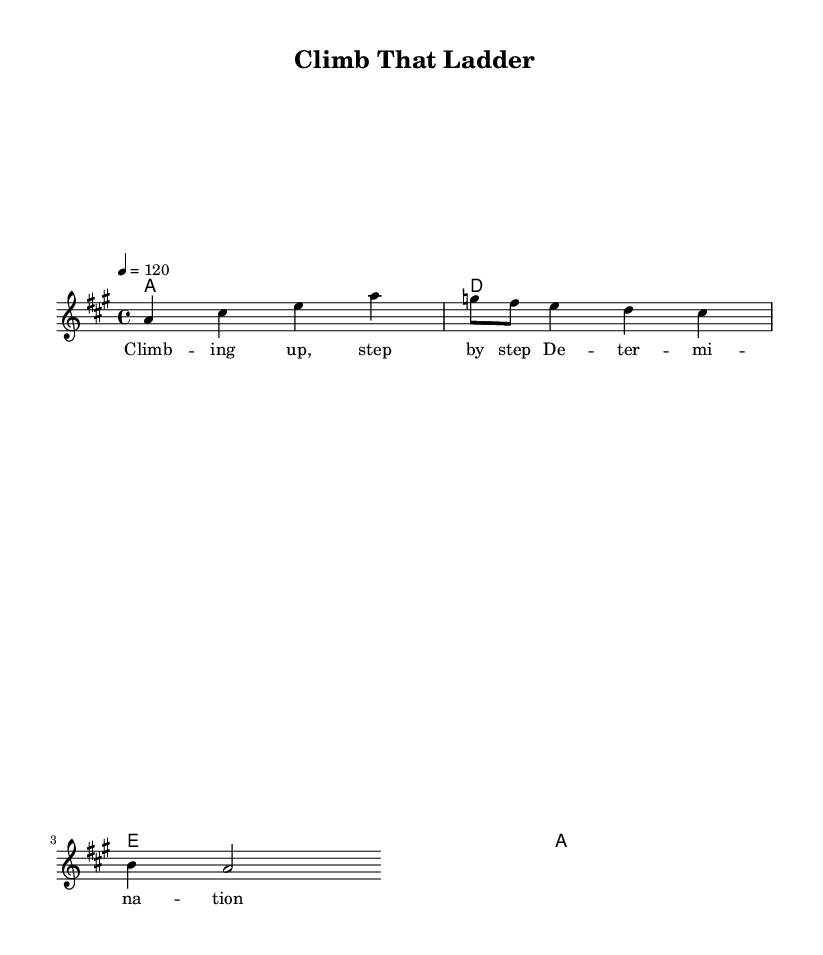What is the key signature of this music? The key signature is A major, which has three sharps (F#, C#, and G#). It is indicated at the beginning of the staff.
Answer: A major What is the time signature of this music? The time signature is 4/4, meaning there are four beats in each measure and the quarter note gets one beat. It is displayed at the beginning of the score.
Answer: 4/4 What is the tempo marking for this piece? The tempo marking indicates a speed of 120 beats per minute and is marked above the staff, denoting a lively pace typical for disco tracks.
Answer: 120 How many measures are in the melody? The melody has a total of 8 measures, which can be counted by analyzing the grouping of notes and rests.
Answer: 8 What is the main theme of the lyrics? The lyrics emphasize determination and perseverance, aligning with the motivational theme often found in disco music. This is evident from the key phrases in the text.
Answer: Determination What chords are used in this score? The score features four chords: A, D, E, and A, which are typical in disco arrangements and provide a strong harmonic foundation. These chords are specified in the chord names section.
Answer: A, D, E What type of lyrics are presented in this piece? The lyrics are motivational, promoting a message of empowerment and achieving success through hard work, which is characteristic of disco music intended for achievers.
Answer: Motivational 